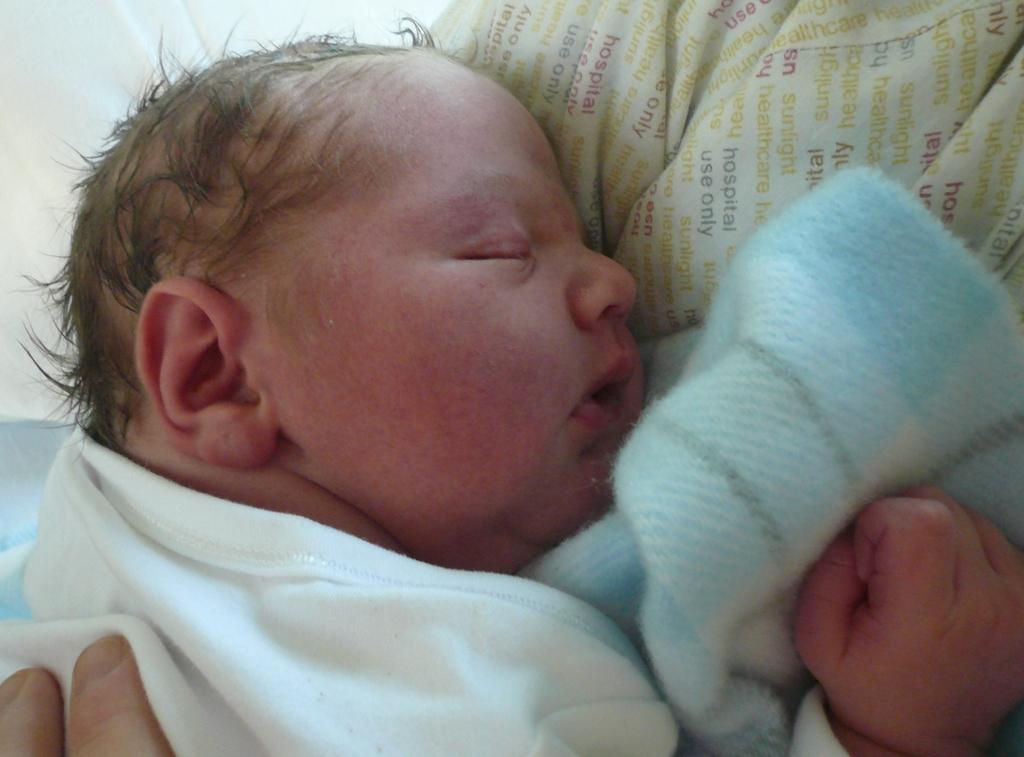What is the main subject of the image? There is a baby sleeping in the image. What is the baby lying on? The baby is on a cloth with text. Are there any other cloths in the image? Yes, there is another cloth in the image. Where can fingers be seen in the image? Fingers are visible in the left bottom corner of the image. What type of soap is being used to clean the baby in the image? There is no soap or cleaning activity depicted in the image; the baby is sleeping on a cloth. What rule is being enforced by the person holding the baby in the image? There is no person holding the baby in the image, and no rule is being enforced. 